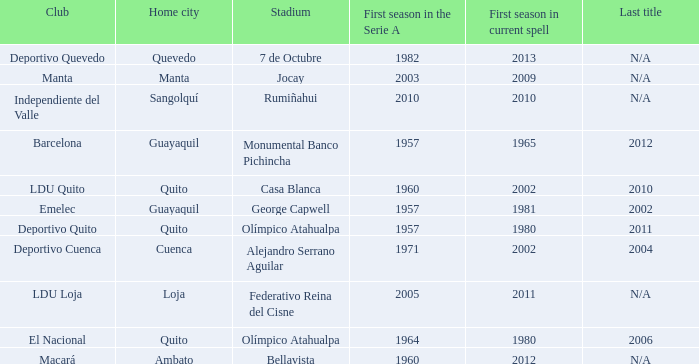Name the most for first season in the serie a for 7 de octubre 1982.0. 